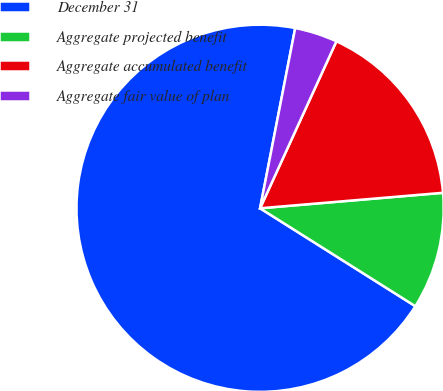<chart> <loc_0><loc_0><loc_500><loc_500><pie_chart><fcel>December 31<fcel>Aggregate projected benefit<fcel>Aggregate accumulated benefit<fcel>Aggregate fair value of plan<nl><fcel>69.11%<fcel>10.3%<fcel>16.83%<fcel>3.76%<nl></chart> 